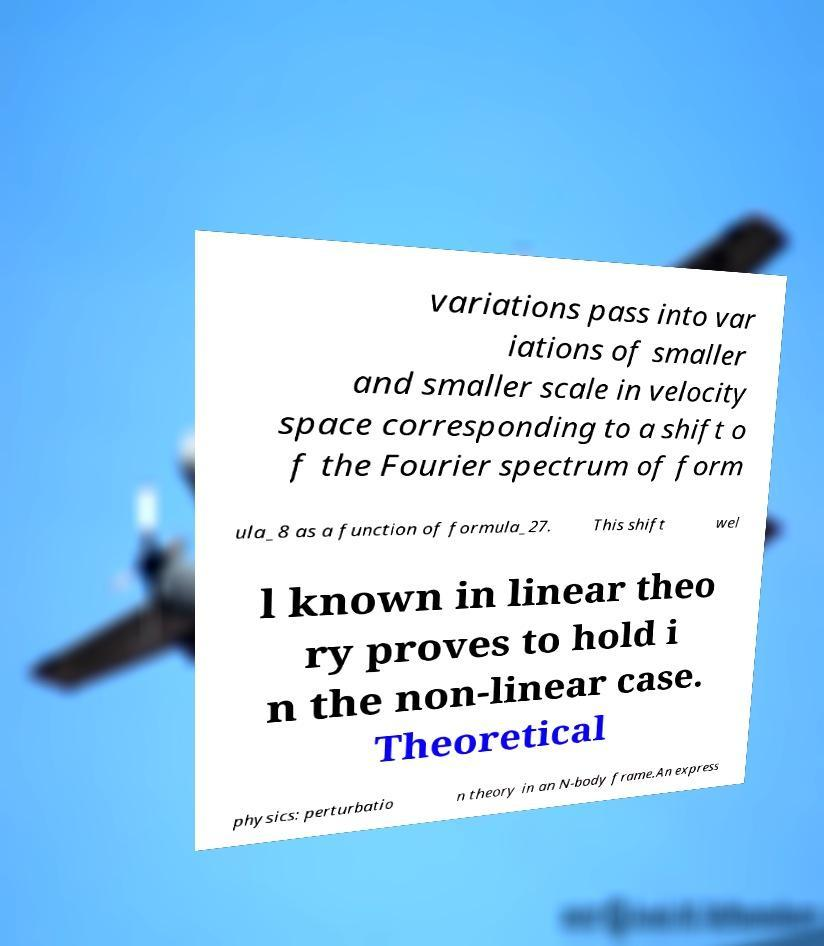I need the written content from this picture converted into text. Can you do that? variations pass into var iations of smaller and smaller scale in velocity space corresponding to a shift o f the Fourier spectrum of form ula_8 as a function of formula_27. This shift wel l known in linear theo ry proves to hold i n the non-linear case. Theoretical physics: perturbatio n theory in an N-body frame.An express 